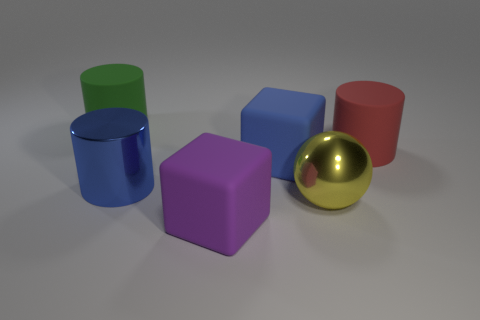What is the color of the matte cylinder that is to the left of the big purple block?
Give a very brief answer. Green. There is a object behind the big rubber cylinder that is to the right of the matte object that is behind the large red rubber thing; what is its material?
Make the answer very short. Rubber. Is there another metallic thing that has the same shape as the large red thing?
Make the answer very short. Yes. What is the shape of the yellow shiny object that is the same size as the red object?
Ensure brevity in your answer.  Sphere. How many big rubber things are both behind the large metallic ball and in front of the large yellow object?
Offer a terse response. 0. Are there fewer big green matte objects that are in front of the large red rubber cylinder than large blue metallic things?
Offer a very short reply. Yes. Is there a yellow matte ball that has the same size as the red cylinder?
Make the answer very short. No. What color is the thing that is made of the same material as the large blue cylinder?
Provide a short and direct response. Yellow. What number of big things are to the left of the large rubber cylinder that is in front of the green rubber cylinder?
Offer a terse response. 5. There is a cylinder that is behind the large blue shiny cylinder and on the left side of the big red rubber cylinder; what is its material?
Keep it short and to the point. Rubber. 